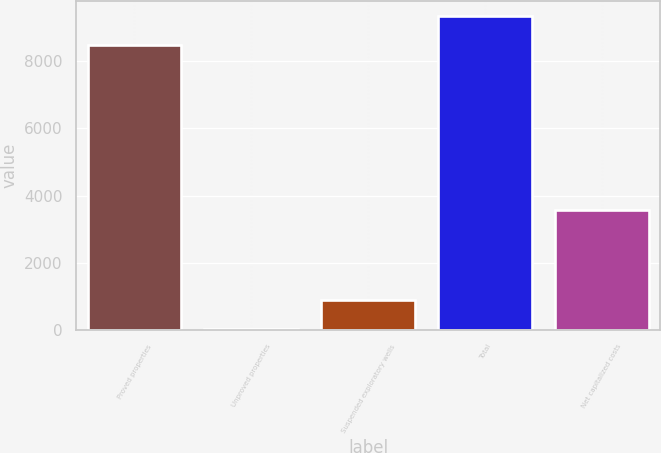<chart> <loc_0><loc_0><loc_500><loc_500><bar_chart><fcel>Proved properties<fcel>Unproved properties<fcel>Suspended exploratory wells<fcel>Total<fcel>Net capitalized costs<nl><fcel>8460<fcel>53<fcel>904.6<fcel>9311.6<fcel>3573<nl></chart> 